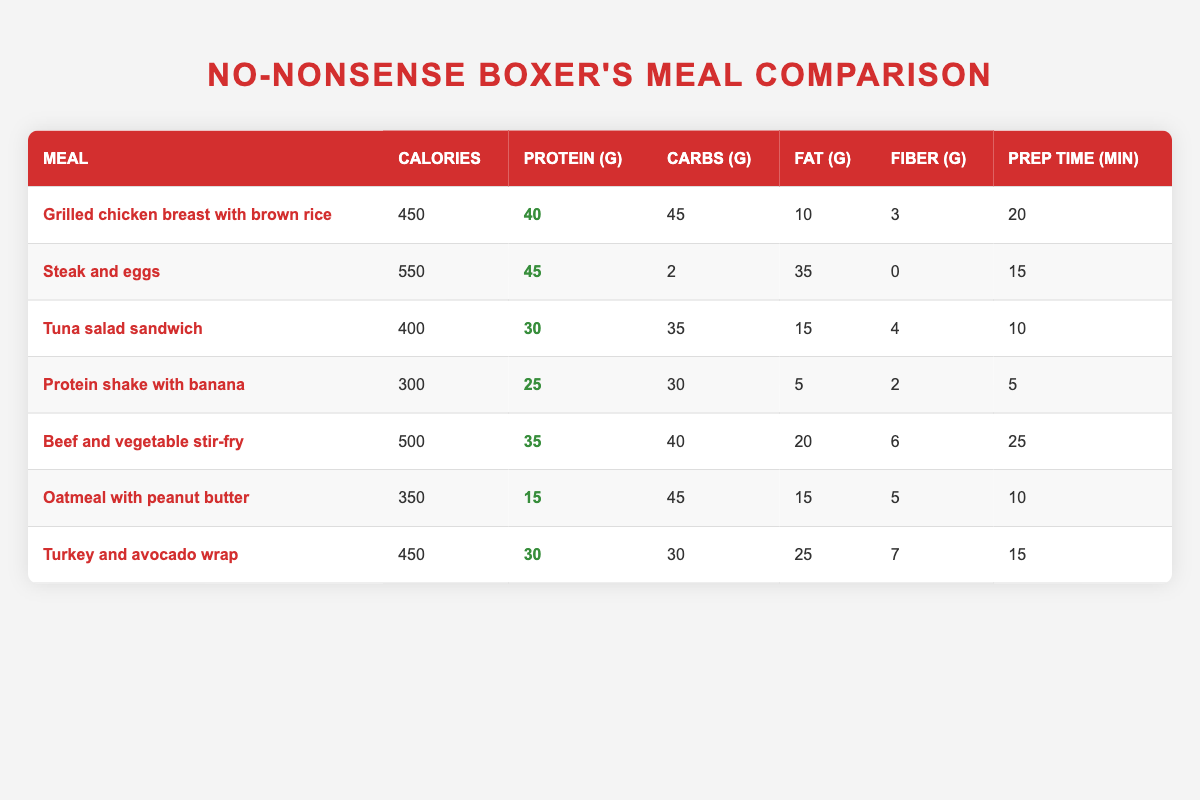What's the meal with the highest protein content? By examining the protein values for each meal, I see that "Steak and eggs" has the highest protein content at 45 grams.
Answer: Steak and eggs How many calories does the "Tuna salad sandwich" have? Looking in the table, under the "Calories" column for the row corresponding to "Tuna salad sandwich," I find it has 400 calories.
Answer: 400 calories Which meal has the least fiber? I check the "Fiber (g)" column across all meals. The meal with the least fiber is "Steak and eggs," which has 0 grams of fiber.
Answer: Steak and eggs What is the total protein content if I combine "Grilled chicken breast with brown rice" and "Turkey and avocado wrap"? First, I find the protein content of each meal: "Grilled chicken breast with brown rice" has 40 grams, and "Turkey and avocado wrap" has 30 grams. Adding them together gives 40 + 30 = 70 grams of protein total.
Answer: 70 grams Is "Beef and vegetable stir-fry" lower in calories than "Grilled chicken breast with brown rice"? I compare the calories of both meals: "Beef and vegetable stir-fry" has 500 calories, while "Grilled chicken breast with brown rice" has 450 calories. Since 500 is greater than 450, the statement is false.
Answer: No What meal has the shortest preparation time? I check the "Prep Time (min)" column. "Protein shake with banana" takes 5 minutes, which is the shortest preparation time compared to the others.
Answer: Protein shake with banana What is the average protein content of the meals listed? To find the average, I add the protein content of all meals: (40 + 45 + 30 + 25 + 35 + 15 + 30) = 250 grams in total. There are 7 meals, so the average protein content is 250/7 = approximately 35.7 grams.
Answer: Approximately 35.7 grams Which meal has the highest fat content? I scan the "Fat (g)" column and find that "Steak and eggs" has 35 grams of fat, which is higher than any other meal listed.
Answer: Steak and eggs 